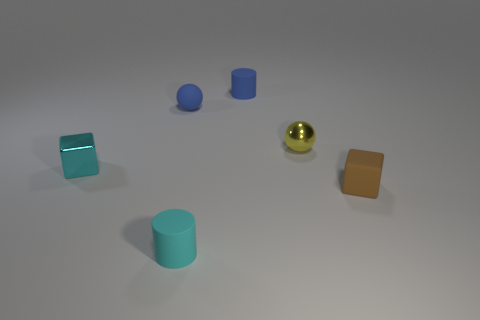The metal object on the right side of the tiny blue ball is what color?
Offer a very short reply. Yellow. There is a tiny rubber thing that is in front of the small cyan metallic thing and left of the blue cylinder; what shape is it?
Your response must be concise. Cylinder. What number of small yellow things are the same shape as the tiny cyan matte thing?
Ensure brevity in your answer.  0. What number of blue rubber spheres are there?
Provide a short and direct response. 1. There is a rubber thing that is both left of the small yellow sphere and in front of the blue ball; what is its size?
Offer a terse response. Small. What is the shape of the metallic object that is the same size as the metal block?
Offer a terse response. Sphere. There is a metallic object right of the small blue matte cylinder; is there a cylinder that is behind it?
Ensure brevity in your answer.  Yes. What is the color of the other tiny object that is the same shape as the cyan shiny thing?
Your response must be concise. Brown. There is a small rubber cylinder in front of the tiny brown rubber object; is its color the same as the tiny shiny cube?
Your answer should be very brief. Yes. How many things are small cyan things right of the blue rubber ball or small blue balls?
Give a very brief answer. 2. 